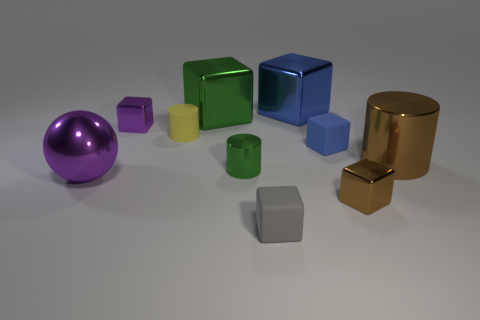Subtract 3 blocks. How many blocks are left? 3 Subtract all brown blocks. How many blocks are left? 5 Subtract all purple metal blocks. How many blocks are left? 5 Subtract all brown blocks. Subtract all blue balls. How many blocks are left? 5 Subtract all blocks. How many objects are left? 4 Subtract all blue shiny blocks. Subtract all brown things. How many objects are left? 7 Add 1 gray blocks. How many gray blocks are left? 2 Add 2 rubber cylinders. How many rubber cylinders exist? 3 Subtract 0 cyan cubes. How many objects are left? 10 